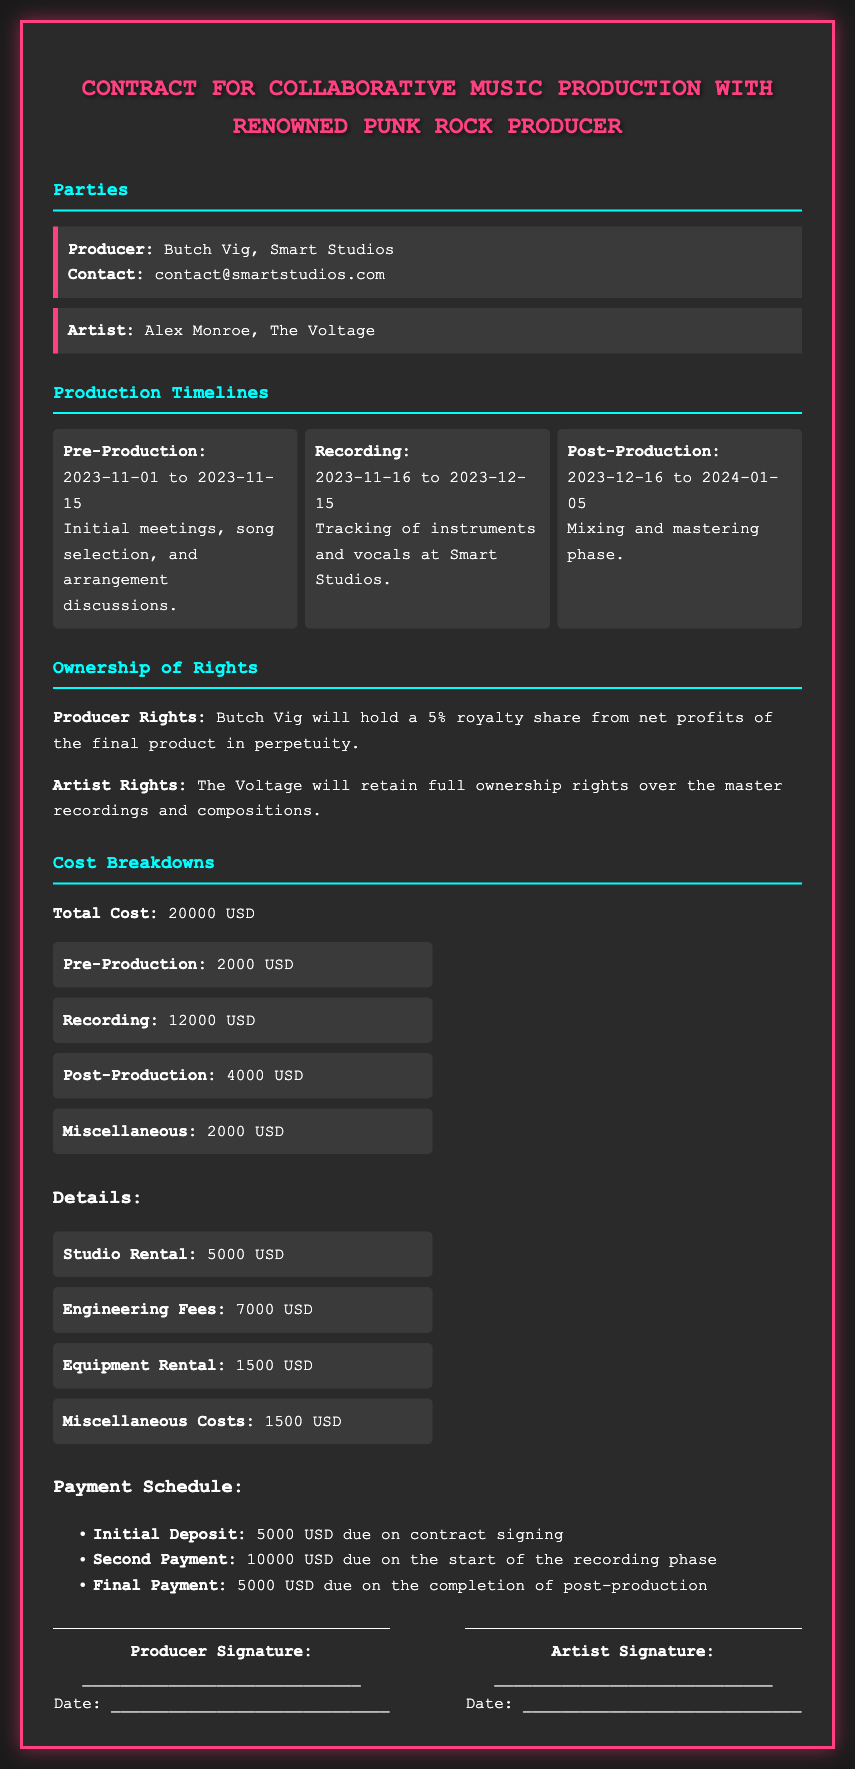what is the name of the producer? The document states that the producer's name is Butch Vig.
Answer: Butch Vig who is the artist? The contract lists the artist as Alex Monroe from The Voltage.
Answer: Alex Monroe what is the total cost of the production? The total cost is clearly mentioned in the document as 20000 USD.
Answer: 20000 USD what is the duration of the recording phase? The recording phase lasts from 2023-11-16 to 2023-12-15, which is a total of 30 days.
Answer: 30 days how much is the initial deposit? The initial deposit amount due upon contract signing is specified as 5000 USD.
Answer: 5000 USD what percentage of royalty share does the producer receive? The document states that Butch Vig will hold a 5% royalty share.
Answer: 5% which phase occurs between November 1 and November 15, 2023? The pre-production phase takes place during this time frame, as outlined in the timeline section.
Answer: Pre-Production how much is allocated for post-production? The cost breakdown indicates that post-production is allocated a total of 4000 USD.
Answer: 4000 USD what is stated regarding the ownership of rights for the artist? The document specifies that The Voltage will retain full ownership rights over the master recordings and compositions.
Answer: Full ownership rights 